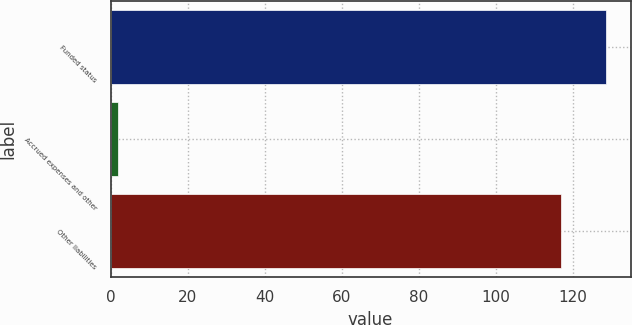<chart> <loc_0><loc_0><loc_500><loc_500><bar_chart><fcel>Funded status<fcel>Accrued expenses and other<fcel>Other liabilities<nl><fcel>128.7<fcel>2<fcel>117<nl></chart> 